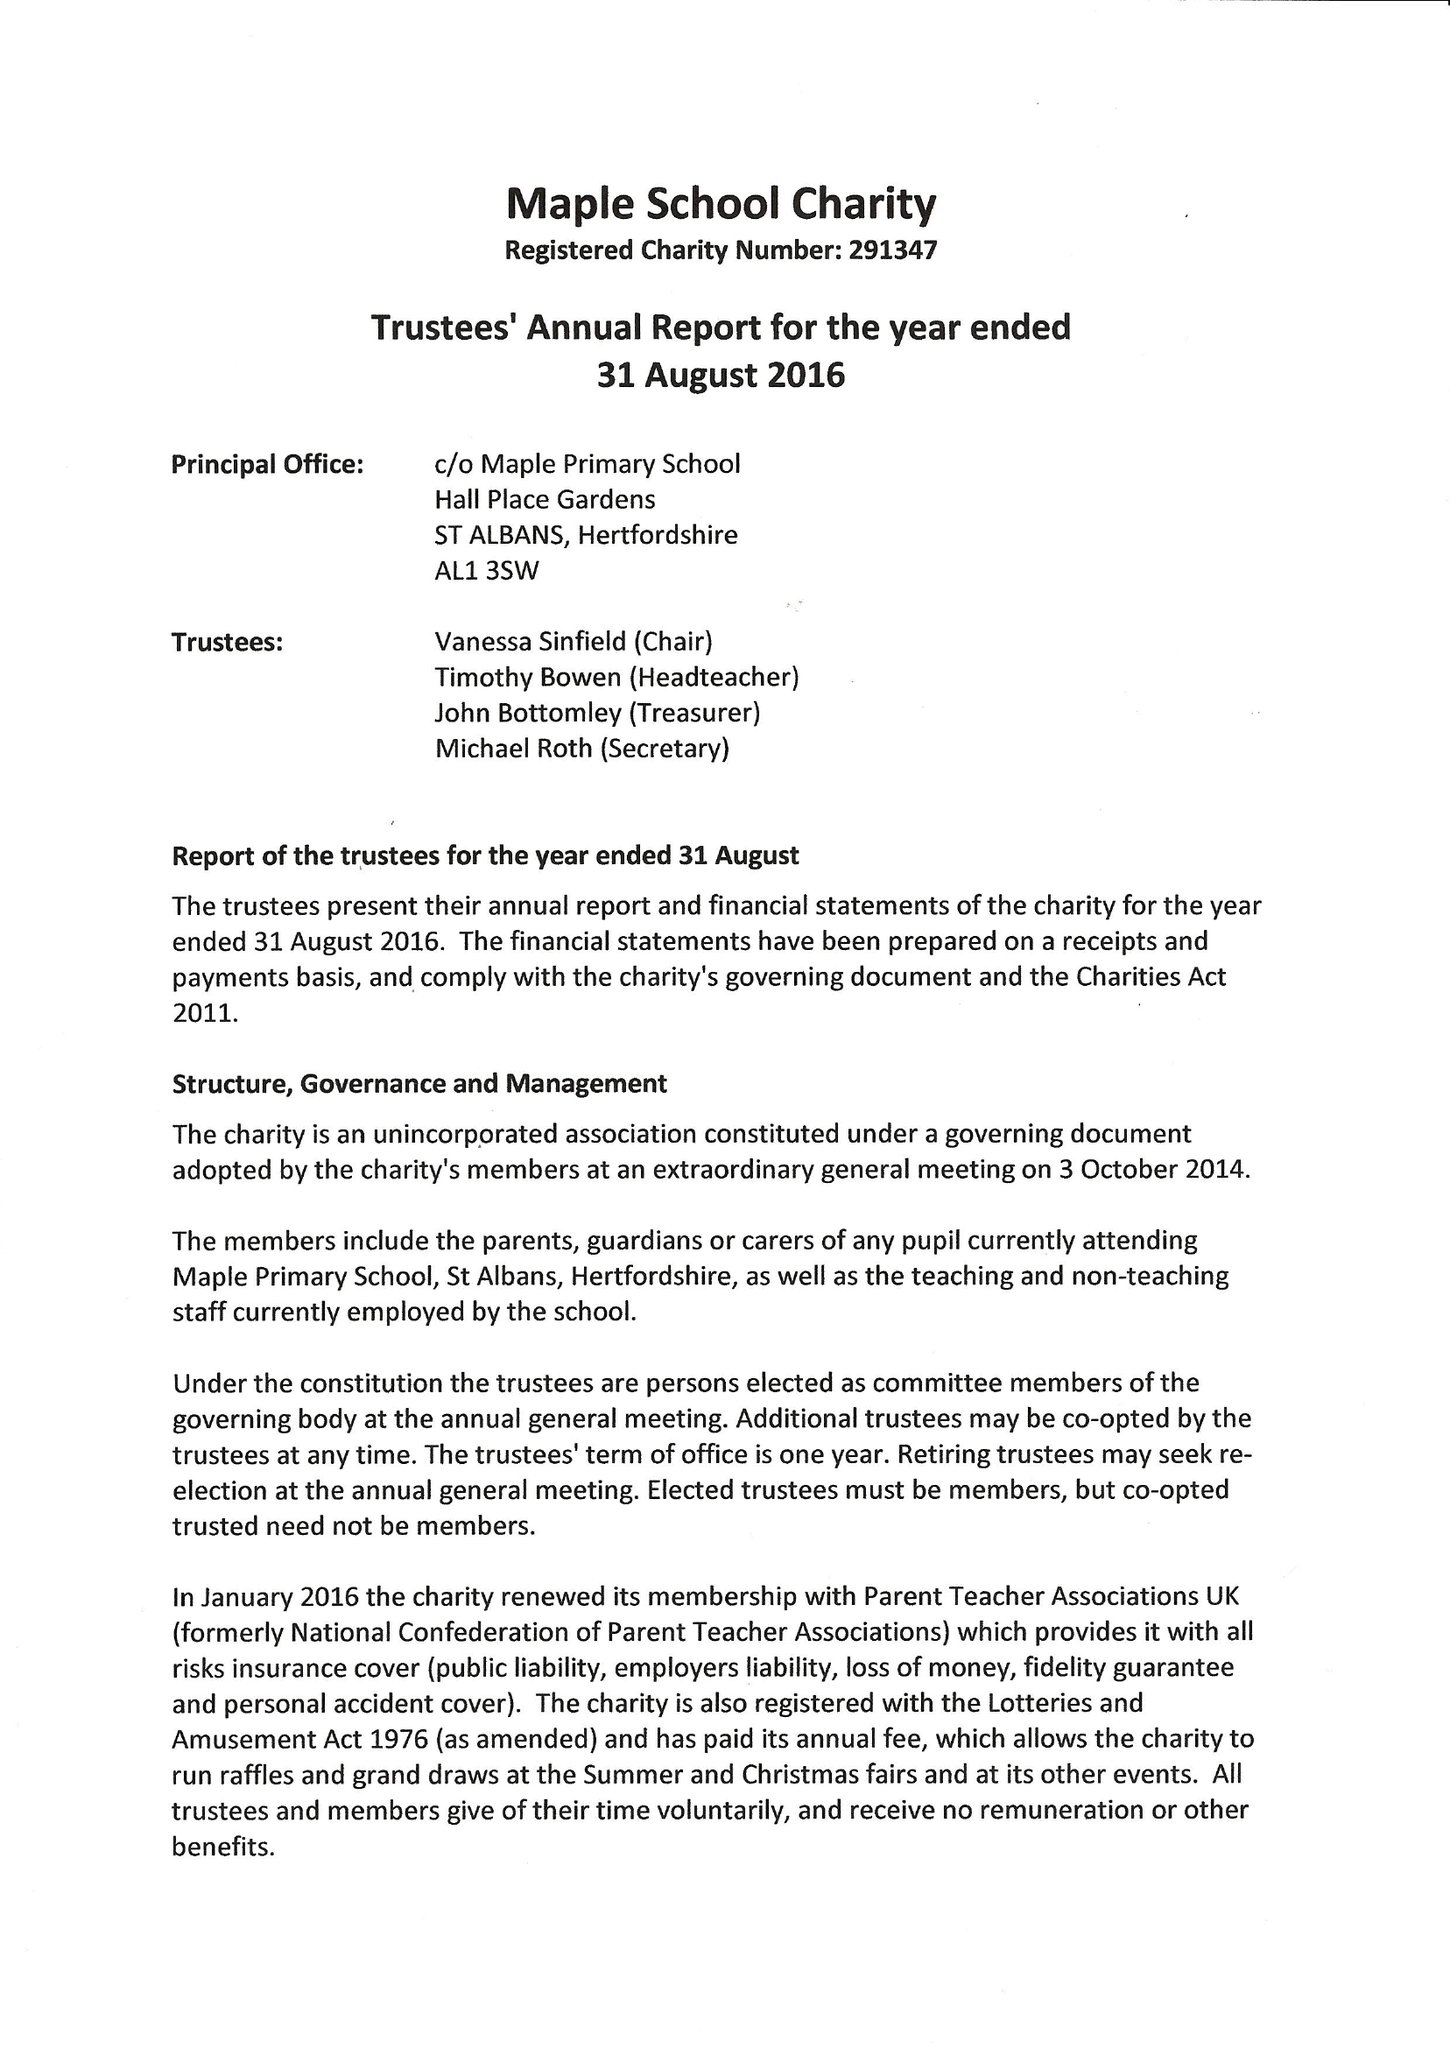What is the value for the spending_annually_in_british_pounds?
Answer the question using a single word or phrase. 22105.00 